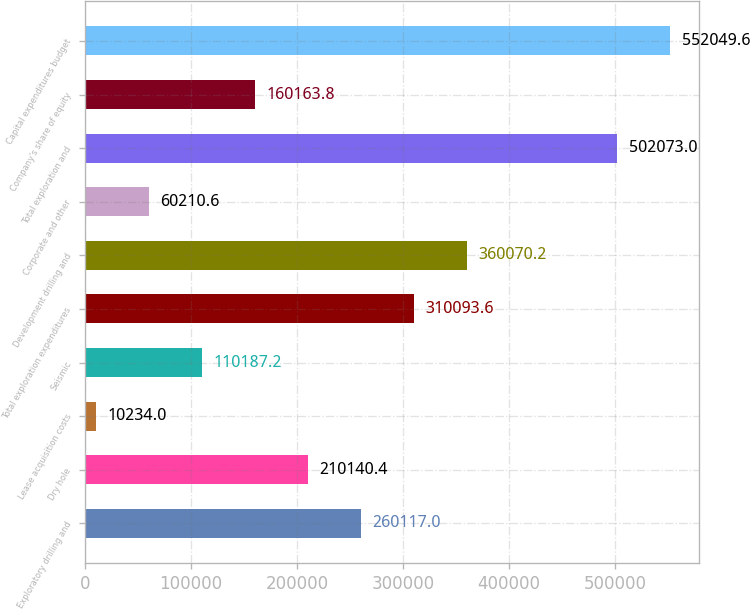<chart> <loc_0><loc_0><loc_500><loc_500><bar_chart><fcel>Exploratory drilling and<fcel>Dry hole<fcel>Lease acquisition costs<fcel>Seismic<fcel>Total exploration expenditures<fcel>Development drilling and<fcel>Corporate and other<fcel>Total exploration and<fcel>Company's share of equity<fcel>Capital expenditures budget<nl><fcel>260117<fcel>210140<fcel>10234<fcel>110187<fcel>310094<fcel>360070<fcel>60210.6<fcel>502073<fcel>160164<fcel>552050<nl></chart> 